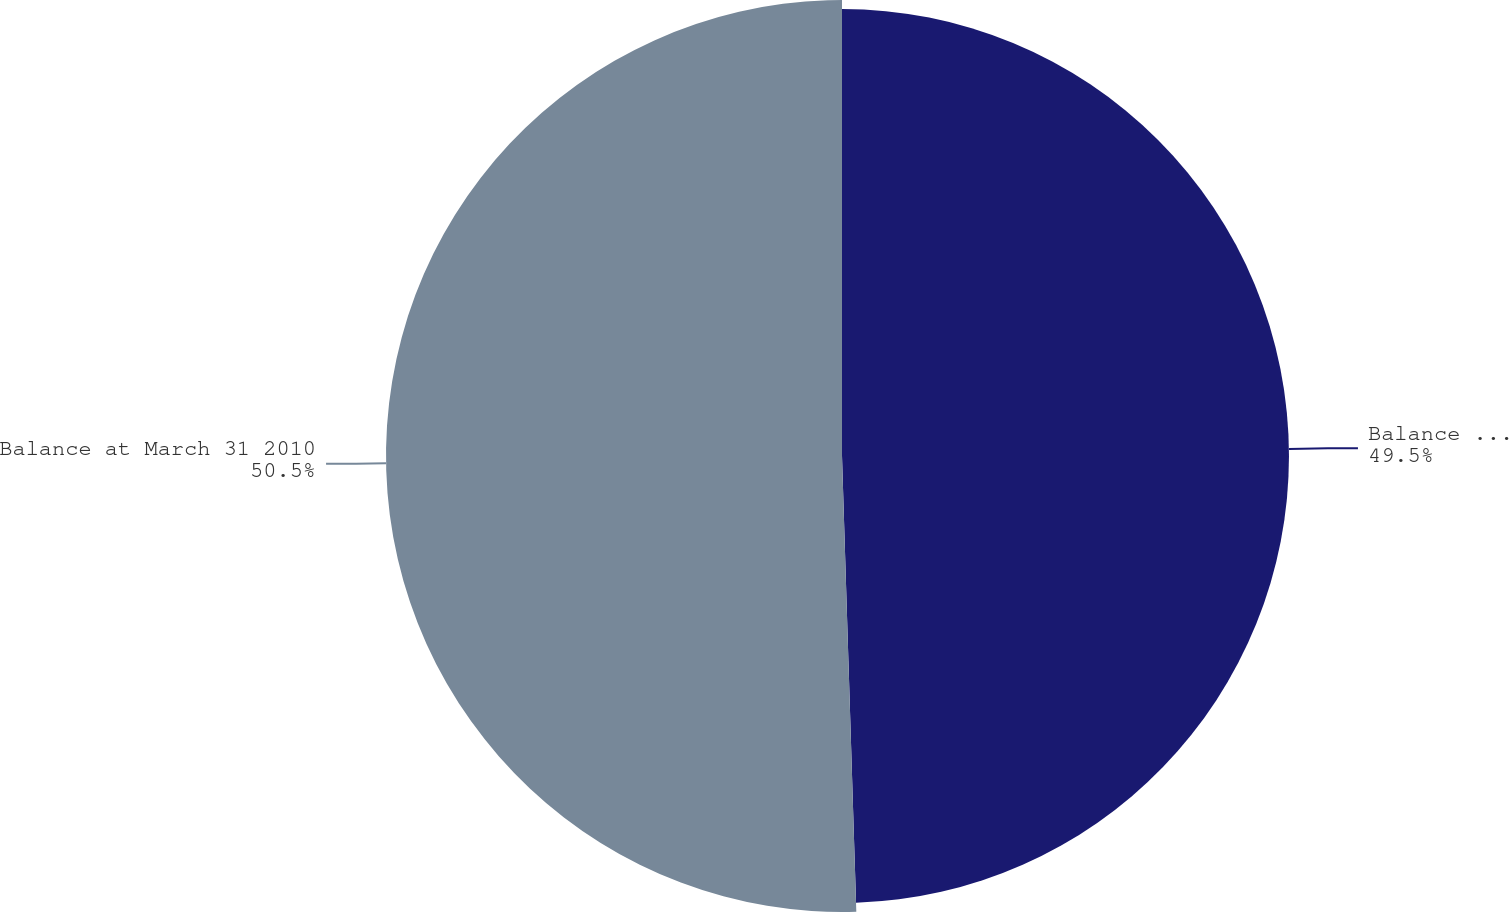<chart> <loc_0><loc_0><loc_500><loc_500><pie_chart><fcel>Balance at March 31 2009<fcel>Balance at March 31 2010<nl><fcel>49.5%<fcel>50.5%<nl></chart> 